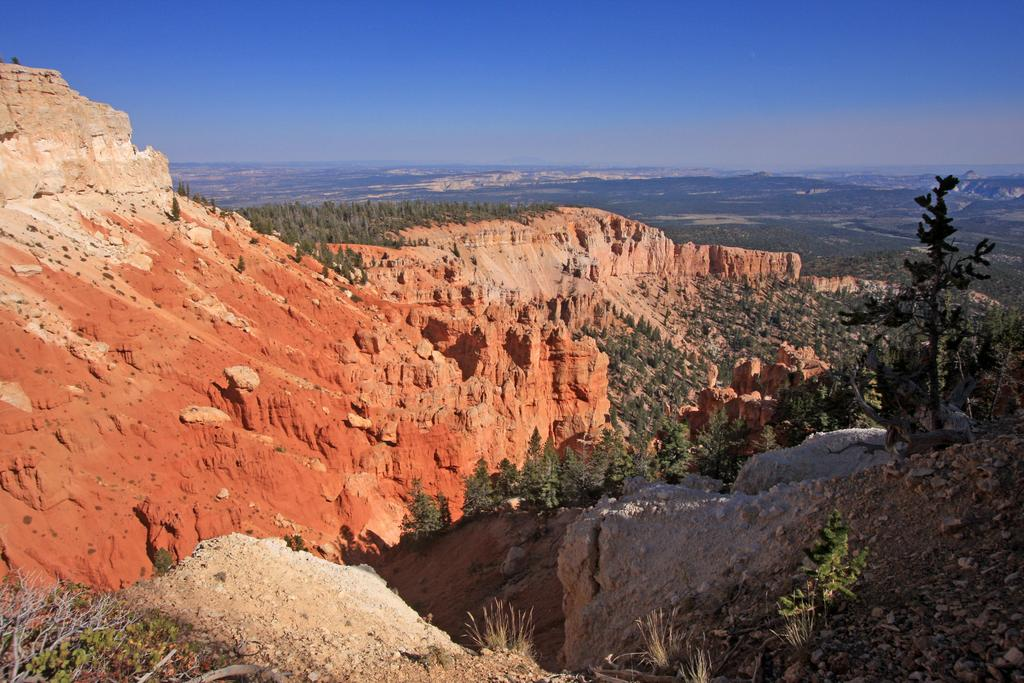What type of geographical feature is present in the image? There are mountains in the image. What is the color of the mountains? The mountains are red in color. What other natural elements can be seen in the image? There are trees in the image. What is visible in the background of the image? The sky is visible in the background of the image. What is the condition of the sky in the image? The sky is clear in the image. Can you see a cub playing near the seashore in the image? There is no cub or seashore present in the image; it features red mountains and trees. What type of things are floating in the sky in the image? There are no things floating in the sky in the image; the sky is clear and empty. 